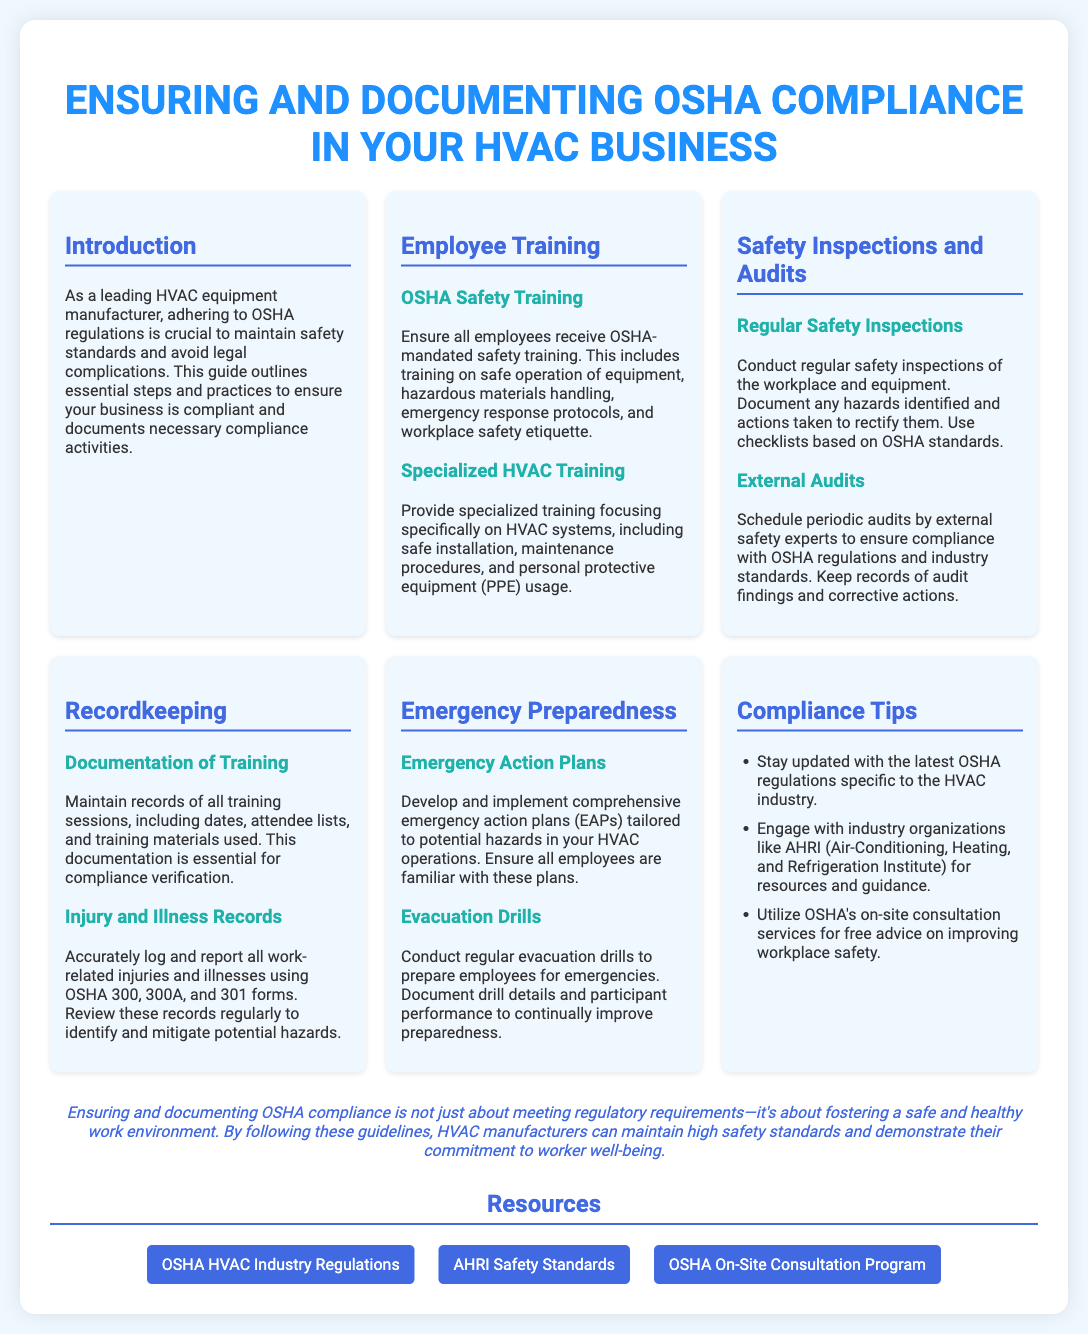what is the title of the poster? The title is prominently displayed at the top of the document and states the focus of the content.
Answer: Ensuring and Documenting OSHA Compliance in Your HVAC Business how many main sections are there in the poster? Each section of the poster is clearly divided, which can be counted for a total.
Answer: 6 what is required for OSHA safety training? This is outlined in the Employee Training section and specifies the types of training.
Answer: Safe operation of equipment, hazardous materials handling, emergency response protocols, and workplace safety etiquette which organization provides safety standards relevant to HVAC? This is mentioned in the Compliance Tips section as a resource for guidance.
Answer: AHRI (Air-Conditioning, Heating, and Refrigeration Institute) what forms are used for logging work-related injuries? The Recordkeeping section details specific forms used for documentation.
Answer: OSHA 300, 300A, and 301 forms what should emergency action plans (EAPs) address? The content under Emergency Preparedness explains the scope of EAPs required.
Answer: Potential hazards in your HVAC operations how often should safety inspections occur? The frequency of these inspections is implied within the Safety Inspections and Audits section.
Answer: Regularly what color is used for the header text? This detail can be noted from the rendering style of the document.
Answer: #1e90ff 